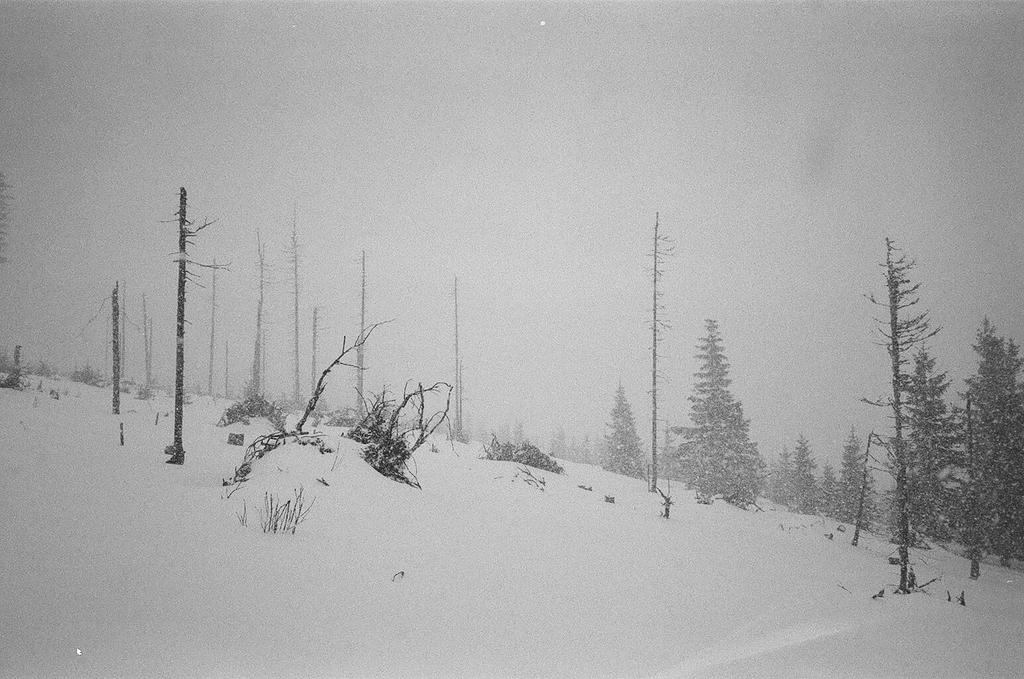What type of vegetation can be seen in the image? There are trees and plants in the image. What structures are present in the image? There are poles in the image. What is the weather like in the image? There is snow visible in the image, indicating a cold or wintry environment. What can be seen in the background of the image? The sky is visible in the background of the image. Are there any slaves visible in the image? There are no slaves present in the image. What type of cable can be seen connecting the poles in the image? There is no cable connecting the poles in the image; only the poles themselves are visible. 